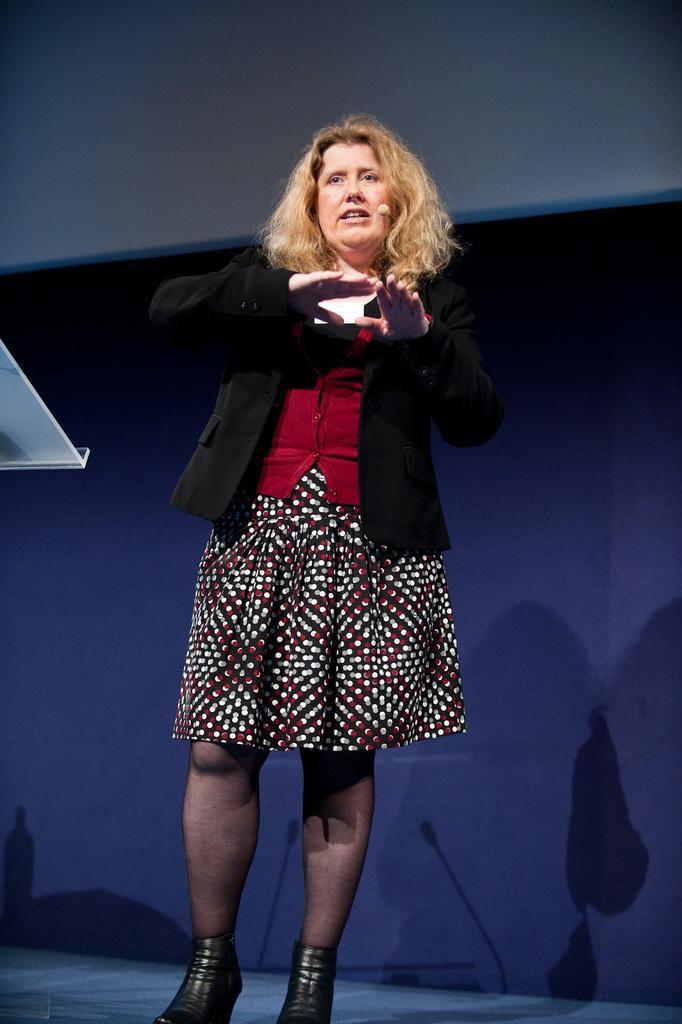In one or two sentences, can you explain what this image depicts? In this picture we can see a woman in the black blazer and she is explaining something. On the left side of the image, there is an object. Behind the woman, there is a wall. On the wall, we can see the shadows of microphones and a woman. 